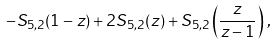<formula> <loc_0><loc_0><loc_500><loc_500>- S _ { 5 , 2 } ( 1 - z ) + 2 S _ { 5 , 2 } ( z ) + S _ { 5 , 2 } \left ( \frac { z } { z - 1 } \right ) \, ,</formula> 